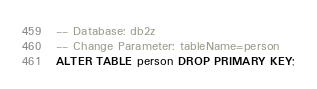Convert code to text. <code><loc_0><loc_0><loc_500><loc_500><_SQL_>-- Database: db2z
-- Change Parameter: tableName=person
ALTER TABLE person DROP PRIMARY KEY;
</code> 